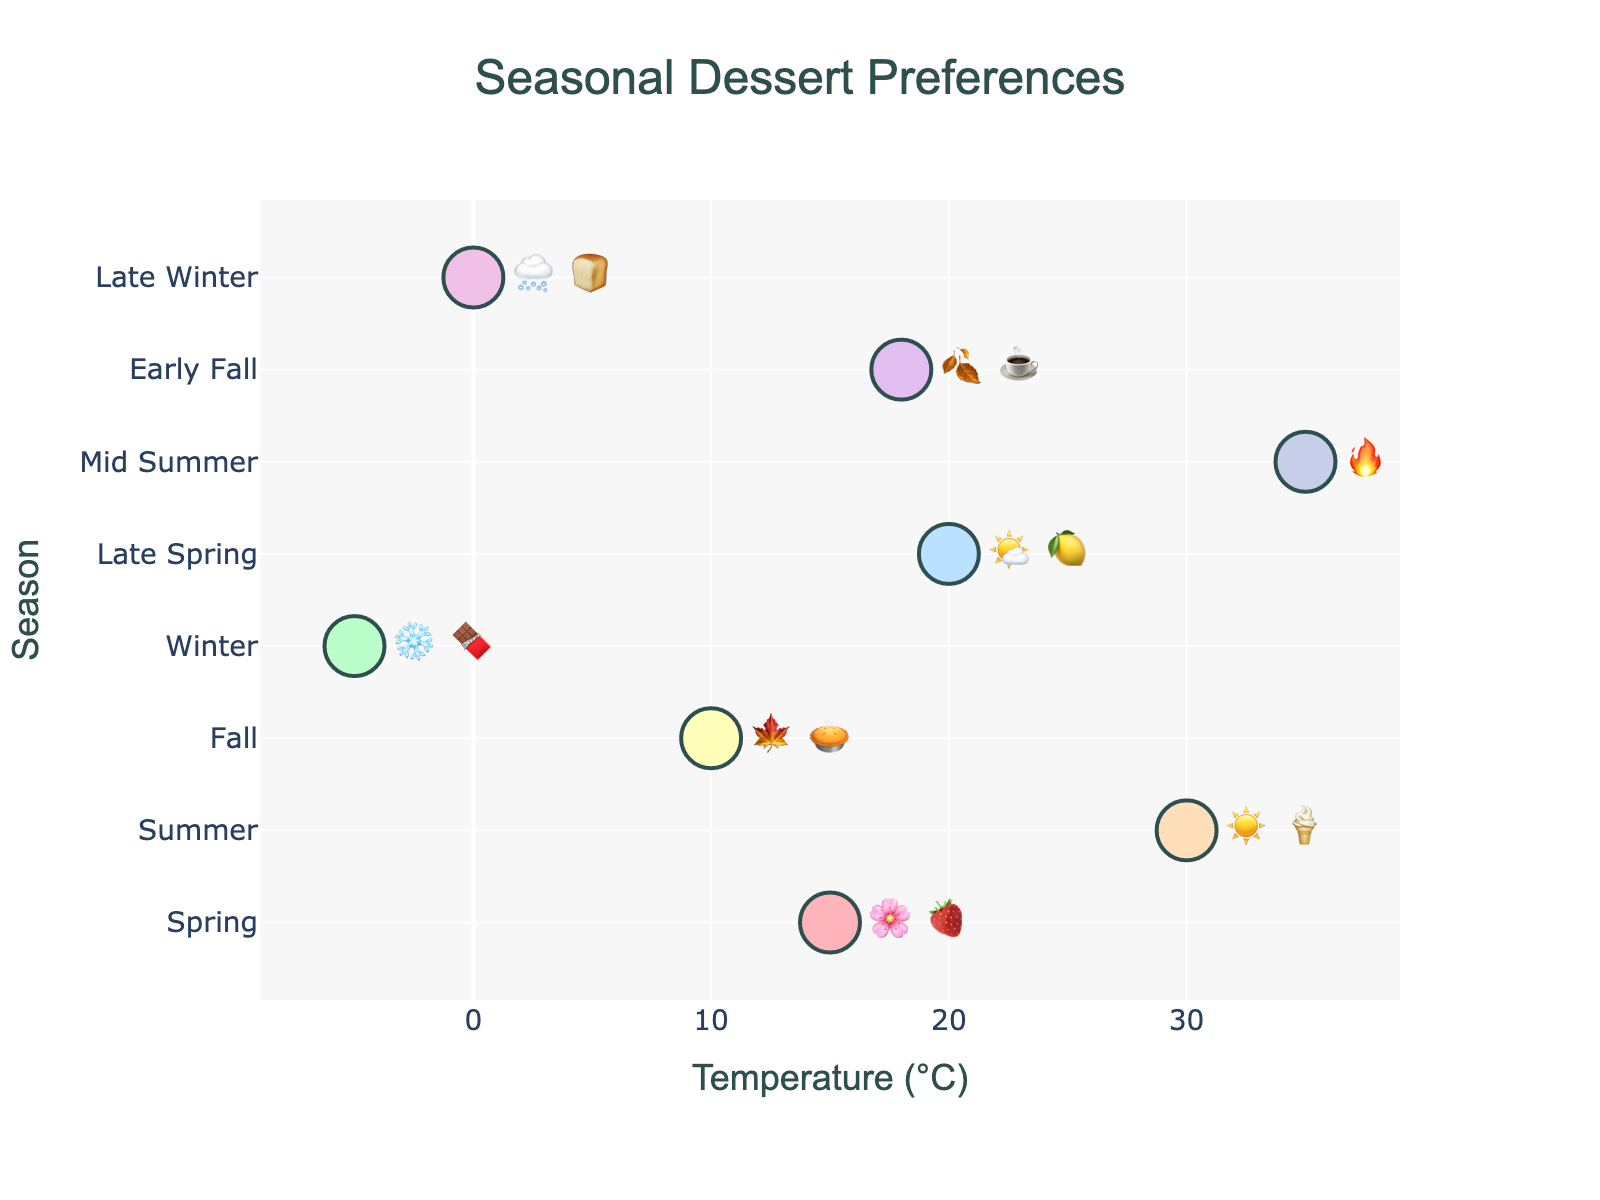What is the preferred dessert during summer? The figure shows a scatter plot with temperature on the x-axis and season on the y-axis. For summer, the plotted emoji pair is ☀️🍦, representing Ice Cream Sundae.
Answer: Ice Cream Sundae Which season has the lowest temperature? The figure displays temperatures along the x-axis for each season on the y-axis. The lowest temperature, -5°C, is in the winter season, indicated by the emoji pair ❄️🍫.
Answer: Winter What dessert is preferred when the temperature is around 0°C? On the x-axis, the 0°C temperature point corresponds with the later winter season, where the plotted emoji pair 🌨️🍞 represents Warm Bread Pudding.
Answer: Warm Bread Pudding How many desserts are preferred in winter and late winter combined? From the y-axis, there are two winter-related entries labeled Winter and Late Winter, associated with ❄️🍫 and 🌨️🍞 respectively. Each entry corresponds to one dessert. Summing these gives a total of two desserts.
Answer: Two Which season has a preferred dessert represented by 🍋🍰? Refer to the y-axis where each season aligns with the plotted emoji pairs. The emoji 🍋🍰 corresponds to Late Spring, where the preferred dessert is Lemon Meringue Pie.
Answer: Late Spring Compare the preferred desserts for spring and late spring. In the chart, the spring is associated with the emoji pair 🌸🍓 (Strawberry Shortcake), and late spring is associated with the emoji pair 🌤️🍋 (Lemon Meringue Pie).
Answer: Strawberry Shortcake in spring and Lemon Meringue Pie in late spring Which dessert is preferred when temperatures are the highest? The highest temperature in the figure is 35°C. This temperature corresponds with mid-summer, indicated by the emoji pair 🔥🍉, representing Watermelon Sorbet.
Answer: Watermelon Sorbet What is the typical dessert preference when temperatures drop below 10°C? For temperatures below 10°C, the relevant points are Winter (-5°C, ❄️🍫 for Hot Chocolate Lava Cake) and Late Winter (0°C, 🌨️🍞 for Warm Bread Pudding).
Answer: Hot Chocolate Lava Cake and Warm Bread Pudding How does the dessert preference change from early fall to late fall? Early fall is represented by 18°C with the emoji pair 🍂☕ (Pumpkin Spice Latte Cheesecake). Late fall is combined with regular fall behaviors, represented by 10°C and the emoji pair 🍁🥧 (Apple Pie).
Answer: Pumpkin Spice Latte Cheesecake to Apple Pie 